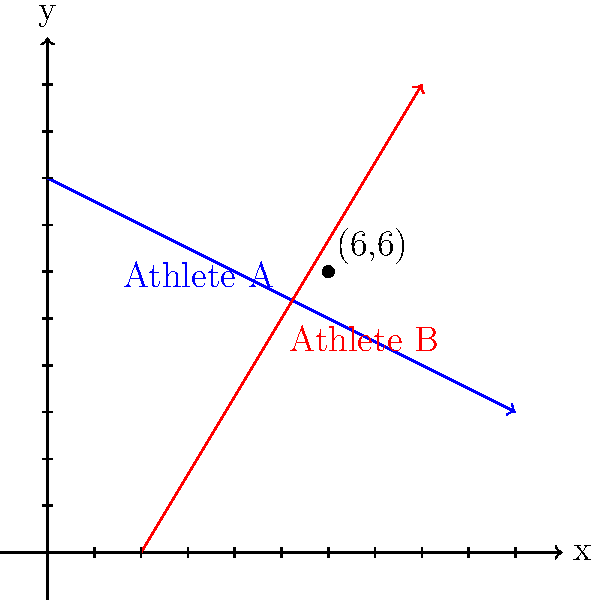Two athletes are running on a sports field represented by a coordinate system. Athlete A starts at point (0,8) and runs towards point (10,3), while Athlete B starts at point (2,0) and runs towards point (8,10). At what point do their paths intersect? To find the intersection point of the two athletes' paths, we need to follow these steps:

1) First, let's find the equations of both lines:

   For Athlete A: 
   Slope = $m_A = \frac{3-8}{10-0} = -\frac{1}{2}$
   Equation: $y = -\frac{1}{2}x + 8$

   For Athlete B:
   Slope = $m_B = \frac{10-0}{8-2} = \frac{5}{3}$
   Equation: $y = \frac{5}{3}x - \frac{10}{3}$

2) To find the intersection, we set these equations equal to each other:

   $-\frac{1}{2}x + 8 = \frac{5}{3}x - \frac{10}{3}$

3) Multiply both sides by 6 to eliminate fractions:

   $-3x + 48 = 10x - 20$

4) Solve for x:

   $-13x = -68$
   $x = \frac{68}{13} = \frac{68}{13} = 6$

5) Substitute this x-value into either equation to find y:

   $y = -\frac{1}{2}(6) + 8 = -3 + 8 = 5$

6) Therefore, the intersection point is (6,6).

This can be verified visually on the graph, where we see the two paths intersecting at the point (6,6).
Answer: (6,6) 